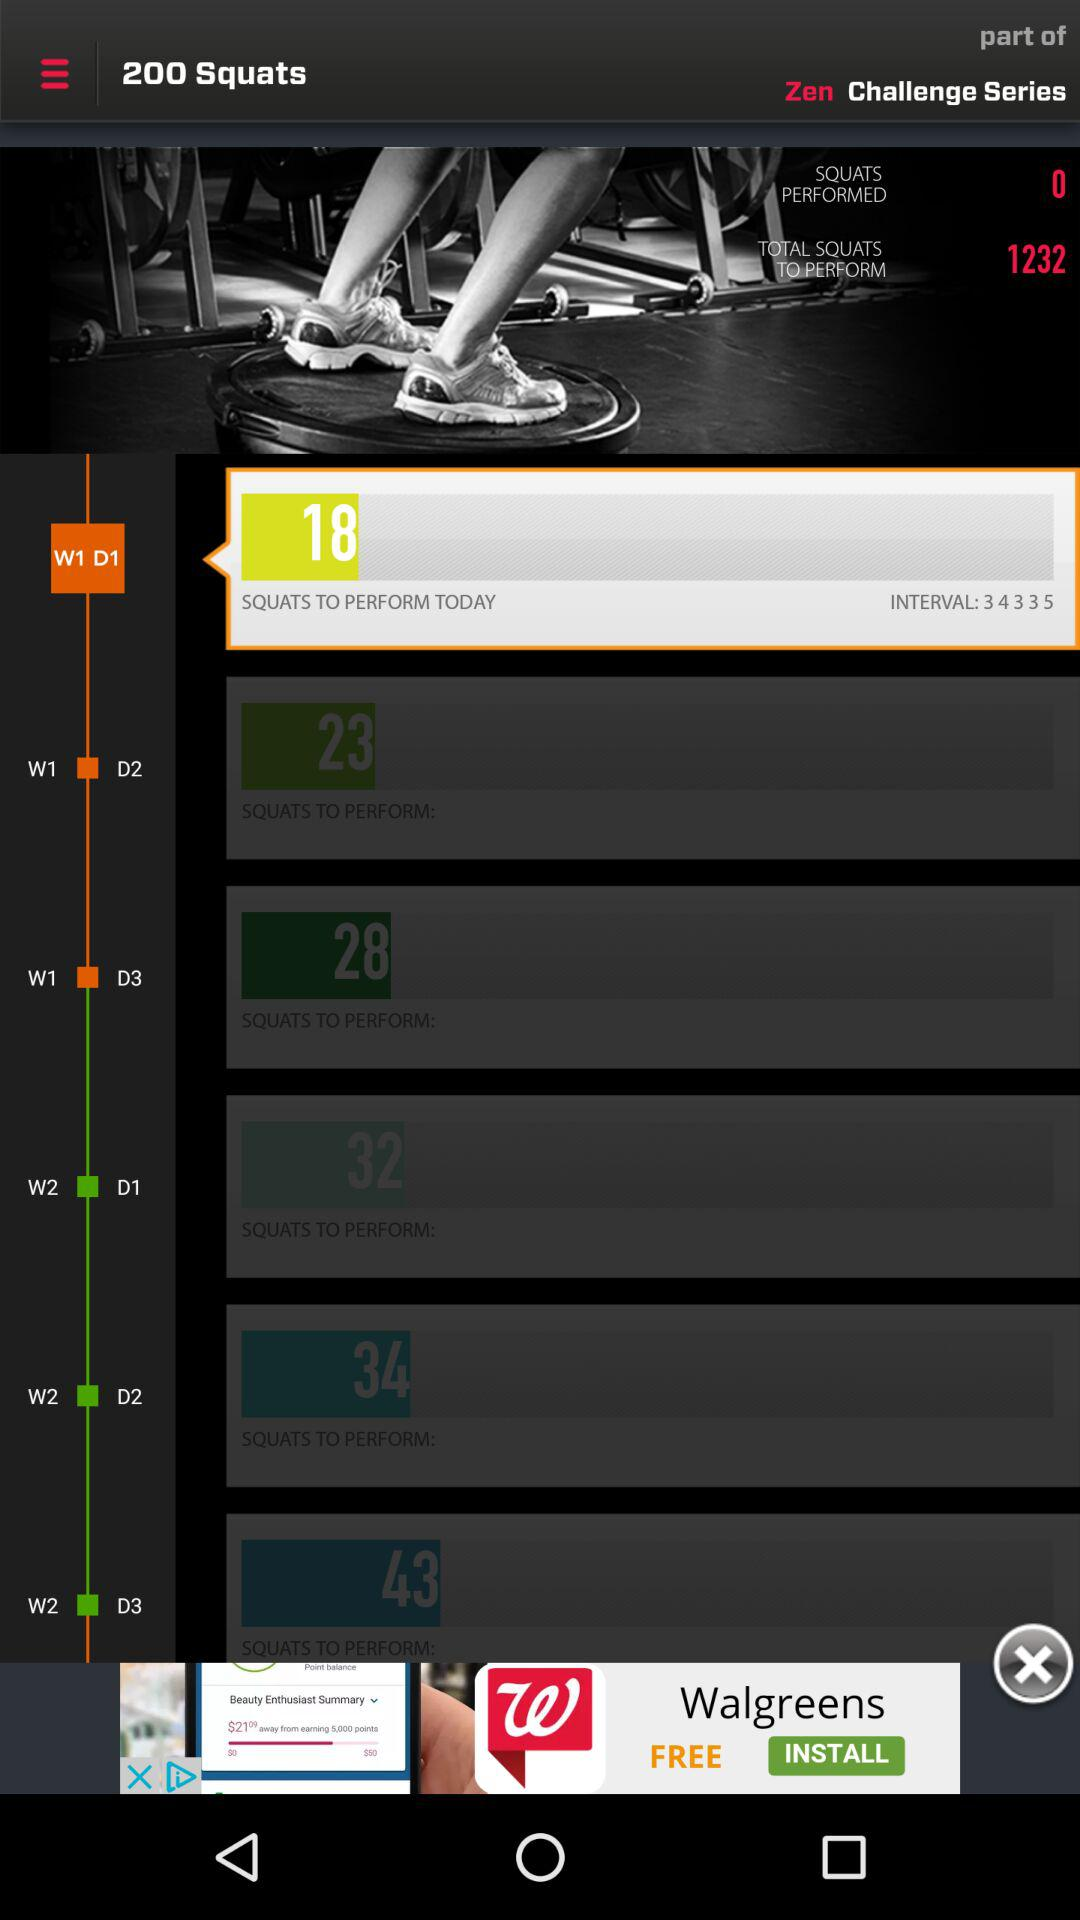How many squats in total are to be performed on Day 3 of Week 2? The number of squats that are to be performed on Day 3 of Week 2 is 43. 